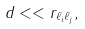Convert formula to latex. <formula><loc_0><loc_0><loc_500><loc_500>d < < r _ { \ell _ { i } \ell _ { j } } ,</formula> 